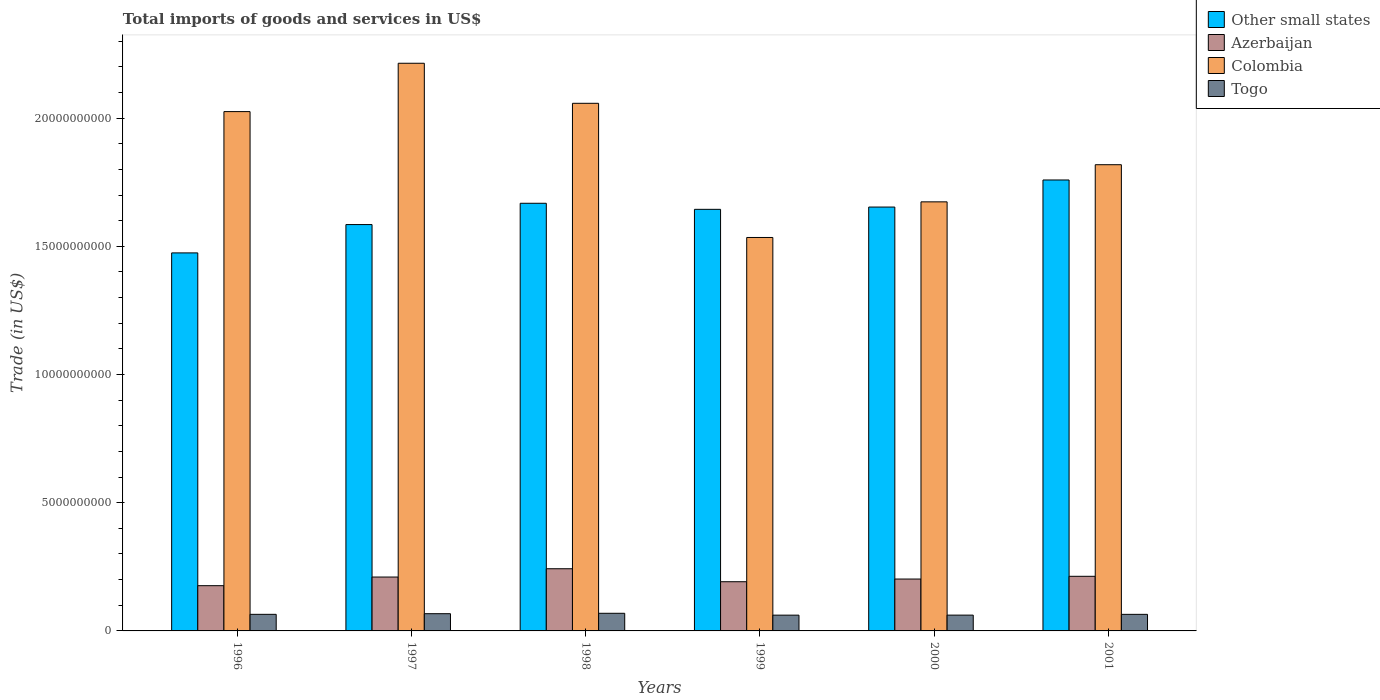How many different coloured bars are there?
Your answer should be very brief. 4. How many groups of bars are there?
Your answer should be compact. 6. Are the number of bars per tick equal to the number of legend labels?
Give a very brief answer. Yes. Are the number of bars on each tick of the X-axis equal?
Make the answer very short. Yes. How many bars are there on the 2nd tick from the right?
Give a very brief answer. 4. What is the label of the 5th group of bars from the left?
Make the answer very short. 2000. What is the total imports of goods and services in Togo in 2000?
Give a very brief answer. 6.16e+08. Across all years, what is the maximum total imports of goods and services in Azerbaijan?
Ensure brevity in your answer.  2.42e+09. Across all years, what is the minimum total imports of goods and services in Other small states?
Your answer should be very brief. 1.47e+1. In which year was the total imports of goods and services in Other small states maximum?
Your answer should be compact. 2001. In which year was the total imports of goods and services in Togo minimum?
Your answer should be very brief. 1999. What is the total total imports of goods and services in Colombia in the graph?
Your response must be concise. 1.13e+11. What is the difference between the total imports of goods and services in Colombia in 1997 and that in 2000?
Give a very brief answer. 5.40e+09. What is the difference between the total imports of goods and services in Azerbaijan in 2000 and the total imports of goods and services in Togo in 1996?
Your answer should be very brief. 1.38e+09. What is the average total imports of goods and services in Togo per year?
Provide a short and direct response. 6.47e+08. In the year 1997, what is the difference between the total imports of goods and services in Other small states and total imports of goods and services in Togo?
Your answer should be compact. 1.52e+1. In how many years, is the total imports of goods and services in Togo greater than 22000000000 US$?
Make the answer very short. 0. What is the ratio of the total imports of goods and services in Azerbaijan in 1996 to that in 1997?
Provide a short and direct response. 0.84. Is the difference between the total imports of goods and services in Other small states in 1997 and 2000 greater than the difference between the total imports of goods and services in Togo in 1997 and 2000?
Your response must be concise. No. What is the difference between the highest and the second highest total imports of goods and services in Azerbaijan?
Offer a very short reply. 2.95e+08. What is the difference between the highest and the lowest total imports of goods and services in Azerbaijan?
Offer a terse response. 6.60e+08. Is the sum of the total imports of goods and services in Colombia in 1998 and 2001 greater than the maximum total imports of goods and services in Togo across all years?
Your answer should be compact. Yes. Is it the case that in every year, the sum of the total imports of goods and services in Togo and total imports of goods and services in Colombia is greater than the sum of total imports of goods and services in Other small states and total imports of goods and services in Azerbaijan?
Provide a succinct answer. Yes. What does the 1st bar from the left in 1997 represents?
Offer a terse response. Other small states. What does the 4th bar from the right in 1998 represents?
Ensure brevity in your answer.  Other small states. Is it the case that in every year, the sum of the total imports of goods and services in Togo and total imports of goods and services in Azerbaijan is greater than the total imports of goods and services in Other small states?
Your response must be concise. No. What is the difference between two consecutive major ticks on the Y-axis?
Ensure brevity in your answer.  5.00e+09. Are the values on the major ticks of Y-axis written in scientific E-notation?
Keep it short and to the point. No. Does the graph contain any zero values?
Offer a very short reply. No. How are the legend labels stacked?
Your response must be concise. Vertical. What is the title of the graph?
Provide a succinct answer. Total imports of goods and services in US$. What is the label or title of the Y-axis?
Provide a short and direct response. Trade (in US$). What is the Trade (in US$) of Other small states in 1996?
Your answer should be very brief. 1.47e+1. What is the Trade (in US$) of Azerbaijan in 1996?
Make the answer very short. 1.76e+09. What is the Trade (in US$) in Colombia in 1996?
Offer a very short reply. 2.03e+1. What is the Trade (in US$) of Togo in 1996?
Provide a succinct answer. 6.47e+08. What is the Trade (in US$) in Other small states in 1997?
Keep it short and to the point. 1.58e+1. What is the Trade (in US$) of Azerbaijan in 1997?
Provide a short and direct response. 2.10e+09. What is the Trade (in US$) in Colombia in 1997?
Make the answer very short. 2.21e+1. What is the Trade (in US$) in Togo in 1997?
Provide a short and direct response. 6.72e+08. What is the Trade (in US$) in Other small states in 1998?
Your answer should be compact. 1.67e+1. What is the Trade (in US$) of Azerbaijan in 1998?
Make the answer very short. 2.42e+09. What is the Trade (in US$) of Colombia in 1998?
Ensure brevity in your answer.  2.06e+1. What is the Trade (in US$) of Togo in 1998?
Your response must be concise. 6.87e+08. What is the Trade (in US$) of Other small states in 1999?
Make the answer very short. 1.64e+1. What is the Trade (in US$) of Azerbaijan in 1999?
Ensure brevity in your answer.  1.92e+09. What is the Trade (in US$) of Colombia in 1999?
Your response must be concise. 1.53e+1. What is the Trade (in US$) in Togo in 1999?
Your answer should be compact. 6.15e+08. What is the Trade (in US$) of Other small states in 2000?
Give a very brief answer. 1.65e+1. What is the Trade (in US$) of Azerbaijan in 2000?
Ensure brevity in your answer.  2.02e+09. What is the Trade (in US$) in Colombia in 2000?
Give a very brief answer. 1.67e+1. What is the Trade (in US$) in Togo in 2000?
Provide a succinct answer. 6.16e+08. What is the Trade (in US$) in Other small states in 2001?
Your answer should be very brief. 1.76e+1. What is the Trade (in US$) of Azerbaijan in 2001?
Make the answer very short. 2.13e+09. What is the Trade (in US$) of Colombia in 2001?
Offer a terse response. 1.82e+1. What is the Trade (in US$) in Togo in 2001?
Your response must be concise. 6.46e+08. Across all years, what is the maximum Trade (in US$) in Other small states?
Ensure brevity in your answer.  1.76e+1. Across all years, what is the maximum Trade (in US$) in Azerbaijan?
Your answer should be compact. 2.42e+09. Across all years, what is the maximum Trade (in US$) of Colombia?
Provide a succinct answer. 2.21e+1. Across all years, what is the maximum Trade (in US$) of Togo?
Give a very brief answer. 6.87e+08. Across all years, what is the minimum Trade (in US$) of Other small states?
Ensure brevity in your answer.  1.47e+1. Across all years, what is the minimum Trade (in US$) of Azerbaijan?
Provide a short and direct response. 1.76e+09. Across all years, what is the minimum Trade (in US$) in Colombia?
Your answer should be very brief. 1.53e+1. Across all years, what is the minimum Trade (in US$) of Togo?
Make the answer very short. 6.15e+08. What is the total Trade (in US$) in Other small states in the graph?
Provide a short and direct response. 9.78e+1. What is the total Trade (in US$) in Azerbaijan in the graph?
Provide a succinct answer. 1.24e+1. What is the total Trade (in US$) of Colombia in the graph?
Make the answer very short. 1.13e+11. What is the total Trade (in US$) in Togo in the graph?
Keep it short and to the point. 3.88e+09. What is the difference between the Trade (in US$) of Other small states in 1996 and that in 1997?
Keep it short and to the point. -1.10e+09. What is the difference between the Trade (in US$) in Azerbaijan in 1996 and that in 1997?
Ensure brevity in your answer.  -3.37e+08. What is the difference between the Trade (in US$) in Colombia in 1996 and that in 1997?
Ensure brevity in your answer.  -1.89e+09. What is the difference between the Trade (in US$) of Togo in 1996 and that in 1997?
Your answer should be very brief. -2.48e+07. What is the difference between the Trade (in US$) in Other small states in 1996 and that in 1998?
Provide a short and direct response. -1.94e+09. What is the difference between the Trade (in US$) in Azerbaijan in 1996 and that in 1998?
Offer a very short reply. -6.60e+08. What is the difference between the Trade (in US$) of Colombia in 1996 and that in 1998?
Your answer should be compact. -3.24e+08. What is the difference between the Trade (in US$) in Togo in 1996 and that in 1998?
Offer a terse response. -4.05e+07. What is the difference between the Trade (in US$) in Other small states in 1996 and that in 1999?
Your answer should be very brief. -1.70e+09. What is the difference between the Trade (in US$) of Azerbaijan in 1996 and that in 1999?
Give a very brief answer. -1.54e+08. What is the difference between the Trade (in US$) in Colombia in 1996 and that in 1999?
Your answer should be compact. 4.91e+09. What is the difference between the Trade (in US$) in Togo in 1996 and that in 1999?
Offer a very short reply. 3.19e+07. What is the difference between the Trade (in US$) of Other small states in 1996 and that in 2000?
Make the answer very short. -1.79e+09. What is the difference between the Trade (in US$) in Azerbaijan in 1996 and that in 2000?
Give a very brief answer. -2.59e+08. What is the difference between the Trade (in US$) in Colombia in 1996 and that in 2000?
Give a very brief answer. 3.52e+09. What is the difference between the Trade (in US$) in Togo in 1996 and that in 2000?
Provide a succinct answer. 3.07e+07. What is the difference between the Trade (in US$) of Other small states in 1996 and that in 2001?
Your response must be concise. -2.84e+09. What is the difference between the Trade (in US$) in Azerbaijan in 1996 and that in 2001?
Make the answer very short. -3.65e+08. What is the difference between the Trade (in US$) of Colombia in 1996 and that in 2001?
Keep it short and to the point. 2.07e+09. What is the difference between the Trade (in US$) in Togo in 1996 and that in 2001?
Give a very brief answer. 8.86e+05. What is the difference between the Trade (in US$) in Other small states in 1997 and that in 1998?
Keep it short and to the point. -8.31e+08. What is the difference between the Trade (in US$) of Azerbaijan in 1997 and that in 1998?
Ensure brevity in your answer.  -3.23e+08. What is the difference between the Trade (in US$) in Colombia in 1997 and that in 1998?
Offer a terse response. 1.56e+09. What is the difference between the Trade (in US$) in Togo in 1997 and that in 1998?
Your answer should be very brief. -1.57e+07. What is the difference between the Trade (in US$) in Other small states in 1997 and that in 1999?
Keep it short and to the point. -5.94e+08. What is the difference between the Trade (in US$) in Azerbaijan in 1997 and that in 1999?
Keep it short and to the point. 1.83e+08. What is the difference between the Trade (in US$) in Colombia in 1997 and that in 1999?
Provide a short and direct response. 6.79e+09. What is the difference between the Trade (in US$) in Togo in 1997 and that in 1999?
Make the answer very short. 5.67e+07. What is the difference between the Trade (in US$) of Other small states in 1997 and that in 2000?
Ensure brevity in your answer.  -6.83e+08. What is the difference between the Trade (in US$) in Azerbaijan in 1997 and that in 2000?
Provide a short and direct response. 7.77e+07. What is the difference between the Trade (in US$) in Colombia in 1997 and that in 2000?
Provide a short and direct response. 5.40e+09. What is the difference between the Trade (in US$) of Togo in 1997 and that in 2000?
Ensure brevity in your answer.  5.55e+07. What is the difference between the Trade (in US$) of Other small states in 1997 and that in 2001?
Your answer should be very brief. -1.74e+09. What is the difference between the Trade (in US$) in Azerbaijan in 1997 and that in 2001?
Ensure brevity in your answer.  -2.88e+07. What is the difference between the Trade (in US$) of Colombia in 1997 and that in 2001?
Provide a succinct answer. 3.96e+09. What is the difference between the Trade (in US$) in Togo in 1997 and that in 2001?
Keep it short and to the point. 2.56e+07. What is the difference between the Trade (in US$) in Other small states in 1998 and that in 1999?
Your answer should be compact. 2.37e+08. What is the difference between the Trade (in US$) of Azerbaijan in 1998 and that in 1999?
Give a very brief answer. 5.06e+08. What is the difference between the Trade (in US$) of Colombia in 1998 and that in 1999?
Provide a succinct answer. 5.23e+09. What is the difference between the Trade (in US$) in Togo in 1998 and that in 1999?
Offer a terse response. 7.24e+07. What is the difference between the Trade (in US$) of Other small states in 1998 and that in 2000?
Your answer should be compact. 1.48e+08. What is the difference between the Trade (in US$) in Azerbaijan in 1998 and that in 2000?
Ensure brevity in your answer.  4.01e+08. What is the difference between the Trade (in US$) of Colombia in 1998 and that in 2000?
Your response must be concise. 3.84e+09. What is the difference between the Trade (in US$) in Togo in 1998 and that in 2000?
Give a very brief answer. 7.12e+07. What is the difference between the Trade (in US$) in Other small states in 1998 and that in 2001?
Your response must be concise. -9.08e+08. What is the difference between the Trade (in US$) in Azerbaijan in 1998 and that in 2001?
Your response must be concise. 2.95e+08. What is the difference between the Trade (in US$) of Colombia in 1998 and that in 2001?
Ensure brevity in your answer.  2.39e+09. What is the difference between the Trade (in US$) of Togo in 1998 and that in 2001?
Provide a short and direct response. 4.14e+07. What is the difference between the Trade (in US$) of Other small states in 1999 and that in 2000?
Keep it short and to the point. -8.91e+07. What is the difference between the Trade (in US$) of Azerbaijan in 1999 and that in 2000?
Provide a short and direct response. -1.05e+08. What is the difference between the Trade (in US$) in Colombia in 1999 and that in 2000?
Give a very brief answer. -1.39e+09. What is the difference between the Trade (in US$) of Togo in 1999 and that in 2000?
Make the answer very short. -1.23e+06. What is the difference between the Trade (in US$) in Other small states in 1999 and that in 2001?
Keep it short and to the point. -1.15e+09. What is the difference between the Trade (in US$) of Azerbaijan in 1999 and that in 2001?
Provide a succinct answer. -2.11e+08. What is the difference between the Trade (in US$) in Colombia in 1999 and that in 2001?
Ensure brevity in your answer.  -2.84e+09. What is the difference between the Trade (in US$) in Togo in 1999 and that in 2001?
Your answer should be very brief. -3.11e+07. What is the difference between the Trade (in US$) in Other small states in 2000 and that in 2001?
Make the answer very short. -1.06e+09. What is the difference between the Trade (in US$) in Azerbaijan in 2000 and that in 2001?
Give a very brief answer. -1.06e+08. What is the difference between the Trade (in US$) of Colombia in 2000 and that in 2001?
Provide a short and direct response. -1.45e+09. What is the difference between the Trade (in US$) of Togo in 2000 and that in 2001?
Ensure brevity in your answer.  -2.98e+07. What is the difference between the Trade (in US$) of Other small states in 1996 and the Trade (in US$) of Azerbaijan in 1997?
Your answer should be compact. 1.26e+1. What is the difference between the Trade (in US$) in Other small states in 1996 and the Trade (in US$) in Colombia in 1997?
Give a very brief answer. -7.40e+09. What is the difference between the Trade (in US$) of Other small states in 1996 and the Trade (in US$) of Togo in 1997?
Provide a succinct answer. 1.41e+1. What is the difference between the Trade (in US$) of Azerbaijan in 1996 and the Trade (in US$) of Colombia in 1997?
Offer a terse response. -2.04e+1. What is the difference between the Trade (in US$) of Azerbaijan in 1996 and the Trade (in US$) of Togo in 1997?
Your answer should be compact. 1.09e+09. What is the difference between the Trade (in US$) in Colombia in 1996 and the Trade (in US$) in Togo in 1997?
Keep it short and to the point. 1.96e+1. What is the difference between the Trade (in US$) in Other small states in 1996 and the Trade (in US$) in Azerbaijan in 1998?
Make the answer very short. 1.23e+1. What is the difference between the Trade (in US$) in Other small states in 1996 and the Trade (in US$) in Colombia in 1998?
Your response must be concise. -5.83e+09. What is the difference between the Trade (in US$) of Other small states in 1996 and the Trade (in US$) of Togo in 1998?
Ensure brevity in your answer.  1.41e+1. What is the difference between the Trade (in US$) of Azerbaijan in 1996 and the Trade (in US$) of Colombia in 1998?
Provide a short and direct response. -1.88e+1. What is the difference between the Trade (in US$) in Azerbaijan in 1996 and the Trade (in US$) in Togo in 1998?
Make the answer very short. 1.08e+09. What is the difference between the Trade (in US$) of Colombia in 1996 and the Trade (in US$) of Togo in 1998?
Your answer should be compact. 1.96e+1. What is the difference between the Trade (in US$) of Other small states in 1996 and the Trade (in US$) of Azerbaijan in 1999?
Provide a succinct answer. 1.28e+1. What is the difference between the Trade (in US$) of Other small states in 1996 and the Trade (in US$) of Colombia in 1999?
Offer a very short reply. -6.01e+08. What is the difference between the Trade (in US$) of Other small states in 1996 and the Trade (in US$) of Togo in 1999?
Your answer should be very brief. 1.41e+1. What is the difference between the Trade (in US$) in Azerbaijan in 1996 and the Trade (in US$) in Colombia in 1999?
Offer a very short reply. -1.36e+1. What is the difference between the Trade (in US$) of Azerbaijan in 1996 and the Trade (in US$) of Togo in 1999?
Offer a terse response. 1.15e+09. What is the difference between the Trade (in US$) of Colombia in 1996 and the Trade (in US$) of Togo in 1999?
Offer a terse response. 1.96e+1. What is the difference between the Trade (in US$) of Other small states in 1996 and the Trade (in US$) of Azerbaijan in 2000?
Offer a terse response. 1.27e+1. What is the difference between the Trade (in US$) of Other small states in 1996 and the Trade (in US$) of Colombia in 2000?
Provide a succinct answer. -1.99e+09. What is the difference between the Trade (in US$) of Other small states in 1996 and the Trade (in US$) of Togo in 2000?
Your answer should be very brief. 1.41e+1. What is the difference between the Trade (in US$) in Azerbaijan in 1996 and the Trade (in US$) in Colombia in 2000?
Make the answer very short. -1.50e+1. What is the difference between the Trade (in US$) in Azerbaijan in 1996 and the Trade (in US$) in Togo in 2000?
Your answer should be compact. 1.15e+09. What is the difference between the Trade (in US$) in Colombia in 1996 and the Trade (in US$) in Togo in 2000?
Provide a succinct answer. 1.96e+1. What is the difference between the Trade (in US$) in Other small states in 1996 and the Trade (in US$) in Azerbaijan in 2001?
Give a very brief answer. 1.26e+1. What is the difference between the Trade (in US$) in Other small states in 1996 and the Trade (in US$) in Colombia in 2001?
Give a very brief answer. -3.44e+09. What is the difference between the Trade (in US$) in Other small states in 1996 and the Trade (in US$) in Togo in 2001?
Offer a terse response. 1.41e+1. What is the difference between the Trade (in US$) in Azerbaijan in 1996 and the Trade (in US$) in Colombia in 2001?
Provide a succinct answer. -1.64e+1. What is the difference between the Trade (in US$) in Azerbaijan in 1996 and the Trade (in US$) in Togo in 2001?
Provide a succinct answer. 1.12e+09. What is the difference between the Trade (in US$) in Colombia in 1996 and the Trade (in US$) in Togo in 2001?
Provide a succinct answer. 1.96e+1. What is the difference between the Trade (in US$) in Other small states in 1997 and the Trade (in US$) in Azerbaijan in 1998?
Keep it short and to the point. 1.34e+1. What is the difference between the Trade (in US$) in Other small states in 1997 and the Trade (in US$) in Colombia in 1998?
Give a very brief answer. -4.73e+09. What is the difference between the Trade (in US$) of Other small states in 1997 and the Trade (in US$) of Togo in 1998?
Provide a succinct answer. 1.52e+1. What is the difference between the Trade (in US$) of Azerbaijan in 1997 and the Trade (in US$) of Colombia in 1998?
Give a very brief answer. -1.85e+1. What is the difference between the Trade (in US$) in Azerbaijan in 1997 and the Trade (in US$) in Togo in 1998?
Your answer should be compact. 1.41e+09. What is the difference between the Trade (in US$) in Colombia in 1997 and the Trade (in US$) in Togo in 1998?
Make the answer very short. 2.15e+1. What is the difference between the Trade (in US$) in Other small states in 1997 and the Trade (in US$) in Azerbaijan in 1999?
Keep it short and to the point. 1.39e+1. What is the difference between the Trade (in US$) in Other small states in 1997 and the Trade (in US$) in Colombia in 1999?
Give a very brief answer. 5.04e+08. What is the difference between the Trade (in US$) of Other small states in 1997 and the Trade (in US$) of Togo in 1999?
Offer a very short reply. 1.52e+1. What is the difference between the Trade (in US$) of Azerbaijan in 1997 and the Trade (in US$) of Colombia in 1999?
Your answer should be compact. -1.32e+1. What is the difference between the Trade (in US$) of Azerbaijan in 1997 and the Trade (in US$) of Togo in 1999?
Give a very brief answer. 1.49e+09. What is the difference between the Trade (in US$) in Colombia in 1997 and the Trade (in US$) in Togo in 1999?
Make the answer very short. 2.15e+1. What is the difference between the Trade (in US$) of Other small states in 1997 and the Trade (in US$) of Azerbaijan in 2000?
Your answer should be very brief. 1.38e+1. What is the difference between the Trade (in US$) in Other small states in 1997 and the Trade (in US$) in Colombia in 2000?
Your response must be concise. -8.86e+08. What is the difference between the Trade (in US$) of Other small states in 1997 and the Trade (in US$) of Togo in 2000?
Keep it short and to the point. 1.52e+1. What is the difference between the Trade (in US$) of Azerbaijan in 1997 and the Trade (in US$) of Colombia in 2000?
Provide a succinct answer. -1.46e+1. What is the difference between the Trade (in US$) in Azerbaijan in 1997 and the Trade (in US$) in Togo in 2000?
Make the answer very short. 1.49e+09. What is the difference between the Trade (in US$) in Colombia in 1997 and the Trade (in US$) in Togo in 2000?
Offer a terse response. 2.15e+1. What is the difference between the Trade (in US$) of Other small states in 1997 and the Trade (in US$) of Azerbaijan in 2001?
Your answer should be very brief. 1.37e+1. What is the difference between the Trade (in US$) of Other small states in 1997 and the Trade (in US$) of Colombia in 2001?
Your response must be concise. -2.33e+09. What is the difference between the Trade (in US$) of Other small states in 1997 and the Trade (in US$) of Togo in 2001?
Keep it short and to the point. 1.52e+1. What is the difference between the Trade (in US$) in Azerbaijan in 1997 and the Trade (in US$) in Colombia in 2001?
Provide a short and direct response. -1.61e+1. What is the difference between the Trade (in US$) in Azerbaijan in 1997 and the Trade (in US$) in Togo in 2001?
Provide a short and direct response. 1.46e+09. What is the difference between the Trade (in US$) in Colombia in 1997 and the Trade (in US$) in Togo in 2001?
Offer a terse response. 2.15e+1. What is the difference between the Trade (in US$) of Other small states in 1998 and the Trade (in US$) of Azerbaijan in 1999?
Offer a terse response. 1.48e+1. What is the difference between the Trade (in US$) in Other small states in 1998 and the Trade (in US$) in Colombia in 1999?
Keep it short and to the point. 1.33e+09. What is the difference between the Trade (in US$) in Other small states in 1998 and the Trade (in US$) in Togo in 1999?
Your answer should be very brief. 1.61e+1. What is the difference between the Trade (in US$) in Azerbaijan in 1998 and the Trade (in US$) in Colombia in 1999?
Your answer should be compact. -1.29e+1. What is the difference between the Trade (in US$) of Azerbaijan in 1998 and the Trade (in US$) of Togo in 1999?
Ensure brevity in your answer.  1.81e+09. What is the difference between the Trade (in US$) in Colombia in 1998 and the Trade (in US$) in Togo in 1999?
Provide a succinct answer. 2.00e+1. What is the difference between the Trade (in US$) of Other small states in 1998 and the Trade (in US$) of Azerbaijan in 2000?
Your answer should be compact. 1.47e+1. What is the difference between the Trade (in US$) in Other small states in 1998 and the Trade (in US$) in Colombia in 2000?
Provide a short and direct response. -5.53e+07. What is the difference between the Trade (in US$) in Other small states in 1998 and the Trade (in US$) in Togo in 2000?
Your answer should be compact. 1.61e+1. What is the difference between the Trade (in US$) of Azerbaijan in 1998 and the Trade (in US$) of Colombia in 2000?
Make the answer very short. -1.43e+1. What is the difference between the Trade (in US$) of Azerbaijan in 1998 and the Trade (in US$) of Togo in 2000?
Offer a very short reply. 1.81e+09. What is the difference between the Trade (in US$) in Colombia in 1998 and the Trade (in US$) in Togo in 2000?
Keep it short and to the point. 2.00e+1. What is the difference between the Trade (in US$) of Other small states in 1998 and the Trade (in US$) of Azerbaijan in 2001?
Provide a succinct answer. 1.45e+1. What is the difference between the Trade (in US$) in Other small states in 1998 and the Trade (in US$) in Colombia in 2001?
Offer a very short reply. -1.50e+09. What is the difference between the Trade (in US$) of Other small states in 1998 and the Trade (in US$) of Togo in 2001?
Your response must be concise. 1.60e+1. What is the difference between the Trade (in US$) of Azerbaijan in 1998 and the Trade (in US$) of Colombia in 2001?
Your response must be concise. -1.58e+1. What is the difference between the Trade (in US$) of Azerbaijan in 1998 and the Trade (in US$) of Togo in 2001?
Make the answer very short. 1.78e+09. What is the difference between the Trade (in US$) of Colombia in 1998 and the Trade (in US$) of Togo in 2001?
Provide a succinct answer. 1.99e+1. What is the difference between the Trade (in US$) of Other small states in 1999 and the Trade (in US$) of Azerbaijan in 2000?
Offer a very short reply. 1.44e+1. What is the difference between the Trade (in US$) in Other small states in 1999 and the Trade (in US$) in Colombia in 2000?
Your answer should be compact. -2.92e+08. What is the difference between the Trade (in US$) of Other small states in 1999 and the Trade (in US$) of Togo in 2000?
Your answer should be very brief. 1.58e+1. What is the difference between the Trade (in US$) in Azerbaijan in 1999 and the Trade (in US$) in Colombia in 2000?
Your answer should be compact. -1.48e+1. What is the difference between the Trade (in US$) of Azerbaijan in 1999 and the Trade (in US$) of Togo in 2000?
Provide a short and direct response. 1.30e+09. What is the difference between the Trade (in US$) of Colombia in 1999 and the Trade (in US$) of Togo in 2000?
Offer a very short reply. 1.47e+1. What is the difference between the Trade (in US$) in Other small states in 1999 and the Trade (in US$) in Azerbaijan in 2001?
Offer a terse response. 1.43e+1. What is the difference between the Trade (in US$) in Other small states in 1999 and the Trade (in US$) in Colombia in 2001?
Make the answer very short. -1.74e+09. What is the difference between the Trade (in US$) of Other small states in 1999 and the Trade (in US$) of Togo in 2001?
Offer a very short reply. 1.58e+1. What is the difference between the Trade (in US$) in Azerbaijan in 1999 and the Trade (in US$) in Colombia in 2001?
Your response must be concise. -1.63e+1. What is the difference between the Trade (in US$) in Azerbaijan in 1999 and the Trade (in US$) in Togo in 2001?
Ensure brevity in your answer.  1.27e+09. What is the difference between the Trade (in US$) in Colombia in 1999 and the Trade (in US$) in Togo in 2001?
Ensure brevity in your answer.  1.47e+1. What is the difference between the Trade (in US$) of Other small states in 2000 and the Trade (in US$) of Azerbaijan in 2001?
Ensure brevity in your answer.  1.44e+1. What is the difference between the Trade (in US$) of Other small states in 2000 and the Trade (in US$) of Colombia in 2001?
Your response must be concise. -1.65e+09. What is the difference between the Trade (in US$) of Other small states in 2000 and the Trade (in US$) of Togo in 2001?
Ensure brevity in your answer.  1.59e+1. What is the difference between the Trade (in US$) of Azerbaijan in 2000 and the Trade (in US$) of Colombia in 2001?
Make the answer very short. -1.62e+1. What is the difference between the Trade (in US$) of Azerbaijan in 2000 and the Trade (in US$) of Togo in 2001?
Ensure brevity in your answer.  1.38e+09. What is the difference between the Trade (in US$) of Colombia in 2000 and the Trade (in US$) of Togo in 2001?
Offer a terse response. 1.61e+1. What is the average Trade (in US$) in Other small states per year?
Your response must be concise. 1.63e+1. What is the average Trade (in US$) in Azerbaijan per year?
Your answer should be very brief. 2.06e+09. What is the average Trade (in US$) of Colombia per year?
Your response must be concise. 1.89e+1. What is the average Trade (in US$) of Togo per year?
Provide a succinct answer. 6.47e+08. In the year 1996, what is the difference between the Trade (in US$) of Other small states and Trade (in US$) of Azerbaijan?
Keep it short and to the point. 1.30e+1. In the year 1996, what is the difference between the Trade (in US$) in Other small states and Trade (in US$) in Colombia?
Provide a short and direct response. -5.51e+09. In the year 1996, what is the difference between the Trade (in US$) of Other small states and Trade (in US$) of Togo?
Give a very brief answer. 1.41e+1. In the year 1996, what is the difference between the Trade (in US$) of Azerbaijan and Trade (in US$) of Colombia?
Your answer should be very brief. -1.85e+1. In the year 1996, what is the difference between the Trade (in US$) of Azerbaijan and Trade (in US$) of Togo?
Your answer should be compact. 1.12e+09. In the year 1996, what is the difference between the Trade (in US$) of Colombia and Trade (in US$) of Togo?
Your response must be concise. 1.96e+1. In the year 1997, what is the difference between the Trade (in US$) of Other small states and Trade (in US$) of Azerbaijan?
Your answer should be very brief. 1.37e+1. In the year 1997, what is the difference between the Trade (in US$) of Other small states and Trade (in US$) of Colombia?
Make the answer very short. -6.29e+09. In the year 1997, what is the difference between the Trade (in US$) of Other small states and Trade (in US$) of Togo?
Offer a very short reply. 1.52e+1. In the year 1997, what is the difference between the Trade (in US$) of Azerbaijan and Trade (in US$) of Colombia?
Offer a very short reply. -2.00e+1. In the year 1997, what is the difference between the Trade (in US$) of Azerbaijan and Trade (in US$) of Togo?
Your response must be concise. 1.43e+09. In the year 1997, what is the difference between the Trade (in US$) of Colombia and Trade (in US$) of Togo?
Your answer should be very brief. 2.15e+1. In the year 1998, what is the difference between the Trade (in US$) in Other small states and Trade (in US$) in Azerbaijan?
Keep it short and to the point. 1.43e+1. In the year 1998, what is the difference between the Trade (in US$) in Other small states and Trade (in US$) in Colombia?
Ensure brevity in your answer.  -3.90e+09. In the year 1998, what is the difference between the Trade (in US$) of Other small states and Trade (in US$) of Togo?
Provide a succinct answer. 1.60e+1. In the year 1998, what is the difference between the Trade (in US$) in Azerbaijan and Trade (in US$) in Colombia?
Provide a succinct answer. -1.82e+1. In the year 1998, what is the difference between the Trade (in US$) in Azerbaijan and Trade (in US$) in Togo?
Offer a terse response. 1.74e+09. In the year 1998, what is the difference between the Trade (in US$) in Colombia and Trade (in US$) in Togo?
Make the answer very short. 1.99e+1. In the year 1999, what is the difference between the Trade (in US$) in Other small states and Trade (in US$) in Azerbaijan?
Offer a terse response. 1.45e+1. In the year 1999, what is the difference between the Trade (in US$) in Other small states and Trade (in US$) in Colombia?
Make the answer very short. 1.10e+09. In the year 1999, what is the difference between the Trade (in US$) of Other small states and Trade (in US$) of Togo?
Your answer should be very brief. 1.58e+1. In the year 1999, what is the difference between the Trade (in US$) in Azerbaijan and Trade (in US$) in Colombia?
Keep it short and to the point. -1.34e+1. In the year 1999, what is the difference between the Trade (in US$) in Azerbaijan and Trade (in US$) in Togo?
Offer a terse response. 1.30e+09. In the year 1999, what is the difference between the Trade (in US$) of Colombia and Trade (in US$) of Togo?
Offer a very short reply. 1.47e+1. In the year 2000, what is the difference between the Trade (in US$) of Other small states and Trade (in US$) of Azerbaijan?
Your response must be concise. 1.45e+1. In the year 2000, what is the difference between the Trade (in US$) of Other small states and Trade (in US$) of Colombia?
Give a very brief answer. -2.03e+08. In the year 2000, what is the difference between the Trade (in US$) of Other small states and Trade (in US$) of Togo?
Keep it short and to the point. 1.59e+1. In the year 2000, what is the difference between the Trade (in US$) in Azerbaijan and Trade (in US$) in Colombia?
Your answer should be very brief. -1.47e+1. In the year 2000, what is the difference between the Trade (in US$) of Azerbaijan and Trade (in US$) of Togo?
Make the answer very short. 1.41e+09. In the year 2000, what is the difference between the Trade (in US$) of Colombia and Trade (in US$) of Togo?
Your answer should be compact. 1.61e+1. In the year 2001, what is the difference between the Trade (in US$) of Other small states and Trade (in US$) of Azerbaijan?
Your answer should be very brief. 1.55e+1. In the year 2001, what is the difference between the Trade (in US$) of Other small states and Trade (in US$) of Colombia?
Keep it short and to the point. -5.96e+08. In the year 2001, what is the difference between the Trade (in US$) of Other small states and Trade (in US$) of Togo?
Provide a succinct answer. 1.69e+1. In the year 2001, what is the difference between the Trade (in US$) in Azerbaijan and Trade (in US$) in Colombia?
Make the answer very short. -1.61e+1. In the year 2001, what is the difference between the Trade (in US$) of Azerbaijan and Trade (in US$) of Togo?
Ensure brevity in your answer.  1.48e+09. In the year 2001, what is the difference between the Trade (in US$) in Colombia and Trade (in US$) in Togo?
Make the answer very short. 1.75e+1. What is the ratio of the Trade (in US$) in Other small states in 1996 to that in 1997?
Ensure brevity in your answer.  0.93. What is the ratio of the Trade (in US$) in Azerbaijan in 1996 to that in 1997?
Offer a very short reply. 0.84. What is the ratio of the Trade (in US$) of Colombia in 1996 to that in 1997?
Your answer should be compact. 0.91. What is the ratio of the Trade (in US$) in Togo in 1996 to that in 1997?
Keep it short and to the point. 0.96. What is the ratio of the Trade (in US$) of Other small states in 1996 to that in 1998?
Keep it short and to the point. 0.88. What is the ratio of the Trade (in US$) of Azerbaijan in 1996 to that in 1998?
Provide a short and direct response. 0.73. What is the ratio of the Trade (in US$) of Colombia in 1996 to that in 1998?
Your answer should be very brief. 0.98. What is the ratio of the Trade (in US$) in Togo in 1996 to that in 1998?
Your answer should be compact. 0.94. What is the ratio of the Trade (in US$) in Other small states in 1996 to that in 1999?
Ensure brevity in your answer.  0.9. What is the ratio of the Trade (in US$) of Azerbaijan in 1996 to that in 1999?
Provide a succinct answer. 0.92. What is the ratio of the Trade (in US$) in Colombia in 1996 to that in 1999?
Your answer should be very brief. 1.32. What is the ratio of the Trade (in US$) in Togo in 1996 to that in 1999?
Give a very brief answer. 1.05. What is the ratio of the Trade (in US$) in Other small states in 1996 to that in 2000?
Your answer should be compact. 0.89. What is the ratio of the Trade (in US$) of Azerbaijan in 1996 to that in 2000?
Give a very brief answer. 0.87. What is the ratio of the Trade (in US$) of Colombia in 1996 to that in 2000?
Provide a succinct answer. 1.21. What is the ratio of the Trade (in US$) in Togo in 1996 to that in 2000?
Your answer should be compact. 1.05. What is the ratio of the Trade (in US$) of Other small states in 1996 to that in 2001?
Your response must be concise. 0.84. What is the ratio of the Trade (in US$) in Azerbaijan in 1996 to that in 2001?
Offer a very short reply. 0.83. What is the ratio of the Trade (in US$) in Colombia in 1996 to that in 2001?
Ensure brevity in your answer.  1.11. What is the ratio of the Trade (in US$) of Togo in 1996 to that in 2001?
Provide a succinct answer. 1. What is the ratio of the Trade (in US$) in Other small states in 1997 to that in 1998?
Your answer should be very brief. 0.95. What is the ratio of the Trade (in US$) in Azerbaijan in 1997 to that in 1998?
Offer a very short reply. 0.87. What is the ratio of the Trade (in US$) of Colombia in 1997 to that in 1998?
Provide a short and direct response. 1.08. What is the ratio of the Trade (in US$) in Togo in 1997 to that in 1998?
Give a very brief answer. 0.98. What is the ratio of the Trade (in US$) of Other small states in 1997 to that in 1999?
Give a very brief answer. 0.96. What is the ratio of the Trade (in US$) in Azerbaijan in 1997 to that in 1999?
Make the answer very short. 1.1. What is the ratio of the Trade (in US$) in Colombia in 1997 to that in 1999?
Give a very brief answer. 1.44. What is the ratio of the Trade (in US$) in Togo in 1997 to that in 1999?
Offer a very short reply. 1.09. What is the ratio of the Trade (in US$) of Other small states in 1997 to that in 2000?
Provide a short and direct response. 0.96. What is the ratio of the Trade (in US$) in Azerbaijan in 1997 to that in 2000?
Ensure brevity in your answer.  1.04. What is the ratio of the Trade (in US$) in Colombia in 1997 to that in 2000?
Give a very brief answer. 1.32. What is the ratio of the Trade (in US$) of Togo in 1997 to that in 2000?
Make the answer very short. 1.09. What is the ratio of the Trade (in US$) in Other small states in 1997 to that in 2001?
Ensure brevity in your answer.  0.9. What is the ratio of the Trade (in US$) in Azerbaijan in 1997 to that in 2001?
Your response must be concise. 0.99. What is the ratio of the Trade (in US$) in Colombia in 1997 to that in 2001?
Offer a very short reply. 1.22. What is the ratio of the Trade (in US$) of Togo in 1997 to that in 2001?
Your answer should be very brief. 1.04. What is the ratio of the Trade (in US$) of Other small states in 1998 to that in 1999?
Your answer should be very brief. 1.01. What is the ratio of the Trade (in US$) of Azerbaijan in 1998 to that in 1999?
Offer a terse response. 1.26. What is the ratio of the Trade (in US$) of Colombia in 1998 to that in 1999?
Give a very brief answer. 1.34. What is the ratio of the Trade (in US$) in Togo in 1998 to that in 1999?
Keep it short and to the point. 1.12. What is the ratio of the Trade (in US$) of Other small states in 1998 to that in 2000?
Make the answer very short. 1.01. What is the ratio of the Trade (in US$) of Azerbaijan in 1998 to that in 2000?
Ensure brevity in your answer.  1.2. What is the ratio of the Trade (in US$) in Colombia in 1998 to that in 2000?
Provide a succinct answer. 1.23. What is the ratio of the Trade (in US$) of Togo in 1998 to that in 2000?
Make the answer very short. 1.12. What is the ratio of the Trade (in US$) in Other small states in 1998 to that in 2001?
Give a very brief answer. 0.95. What is the ratio of the Trade (in US$) of Azerbaijan in 1998 to that in 2001?
Provide a short and direct response. 1.14. What is the ratio of the Trade (in US$) in Colombia in 1998 to that in 2001?
Offer a very short reply. 1.13. What is the ratio of the Trade (in US$) of Togo in 1998 to that in 2001?
Ensure brevity in your answer.  1.06. What is the ratio of the Trade (in US$) in Other small states in 1999 to that in 2000?
Offer a terse response. 0.99. What is the ratio of the Trade (in US$) of Azerbaijan in 1999 to that in 2000?
Give a very brief answer. 0.95. What is the ratio of the Trade (in US$) in Colombia in 1999 to that in 2000?
Offer a very short reply. 0.92. What is the ratio of the Trade (in US$) of Togo in 1999 to that in 2000?
Your answer should be very brief. 1. What is the ratio of the Trade (in US$) in Other small states in 1999 to that in 2001?
Provide a succinct answer. 0.93. What is the ratio of the Trade (in US$) in Azerbaijan in 1999 to that in 2001?
Give a very brief answer. 0.9. What is the ratio of the Trade (in US$) of Colombia in 1999 to that in 2001?
Ensure brevity in your answer.  0.84. What is the ratio of the Trade (in US$) of Togo in 1999 to that in 2001?
Give a very brief answer. 0.95. What is the ratio of the Trade (in US$) in Azerbaijan in 2000 to that in 2001?
Offer a terse response. 0.95. What is the ratio of the Trade (in US$) in Colombia in 2000 to that in 2001?
Make the answer very short. 0.92. What is the ratio of the Trade (in US$) of Togo in 2000 to that in 2001?
Offer a very short reply. 0.95. What is the difference between the highest and the second highest Trade (in US$) in Other small states?
Offer a terse response. 9.08e+08. What is the difference between the highest and the second highest Trade (in US$) in Azerbaijan?
Ensure brevity in your answer.  2.95e+08. What is the difference between the highest and the second highest Trade (in US$) of Colombia?
Your answer should be compact. 1.56e+09. What is the difference between the highest and the second highest Trade (in US$) in Togo?
Make the answer very short. 1.57e+07. What is the difference between the highest and the lowest Trade (in US$) of Other small states?
Offer a very short reply. 2.84e+09. What is the difference between the highest and the lowest Trade (in US$) in Azerbaijan?
Keep it short and to the point. 6.60e+08. What is the difference between the highest and the lowest Trade (in US$) in Colombia?
Give a very brief answer. 6.79e+09. What is the difference between the highest and the lowest Trade (in US$) in Togo?
Ensure brevity in your answer.  7.24e+07. 